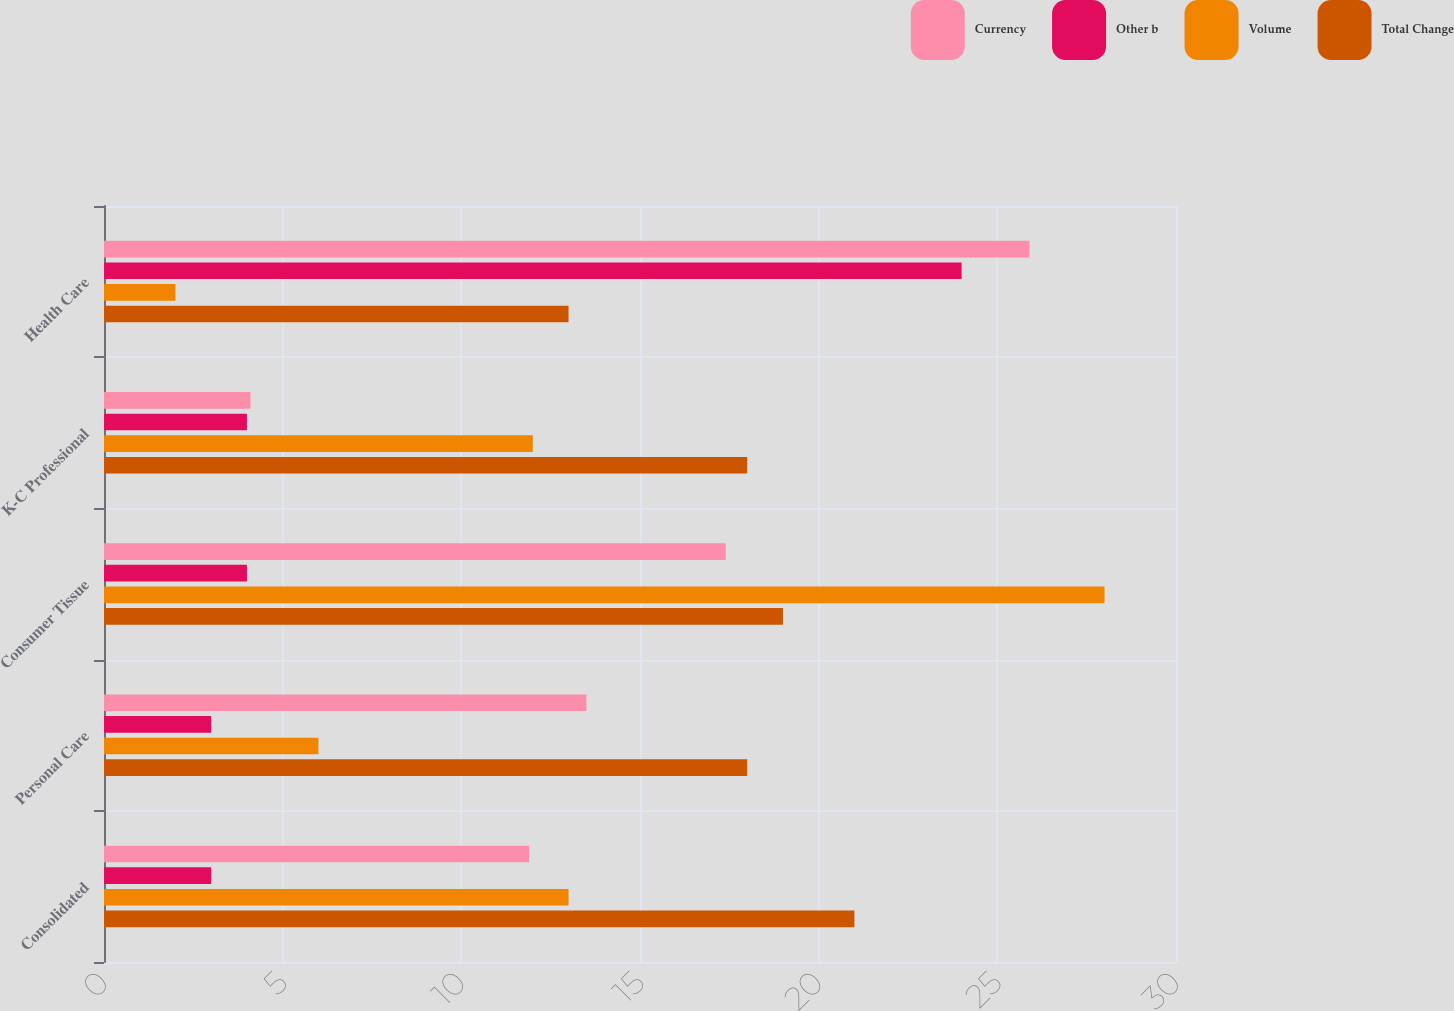Convert chart. <chart><loc_0><loc_0><loc_500><loc_500><stacked_bar_chart><ecel><fcel>Consolidated<fcel>Personal Care<fcel>Consumer Tissue<fcel>K-C Professional<fcel>Health Care<nl><fcel>Currency<fcel>11.9<fcel>13.5<fcel>17.4<fcel>4.1<fcel>25.9<nl><fcel>Other b<fcel>3<fcel>3<fcel>4<fcel>4<fcel>24<nl><fcel>Volume<fcel>13<fcel>6<fcel>28<fcel>12<fcel>2<nl><fcel>Total Change<fcel>21<fcel>18<fcel>19<fcel>18<fcel>13<nl></chart> 